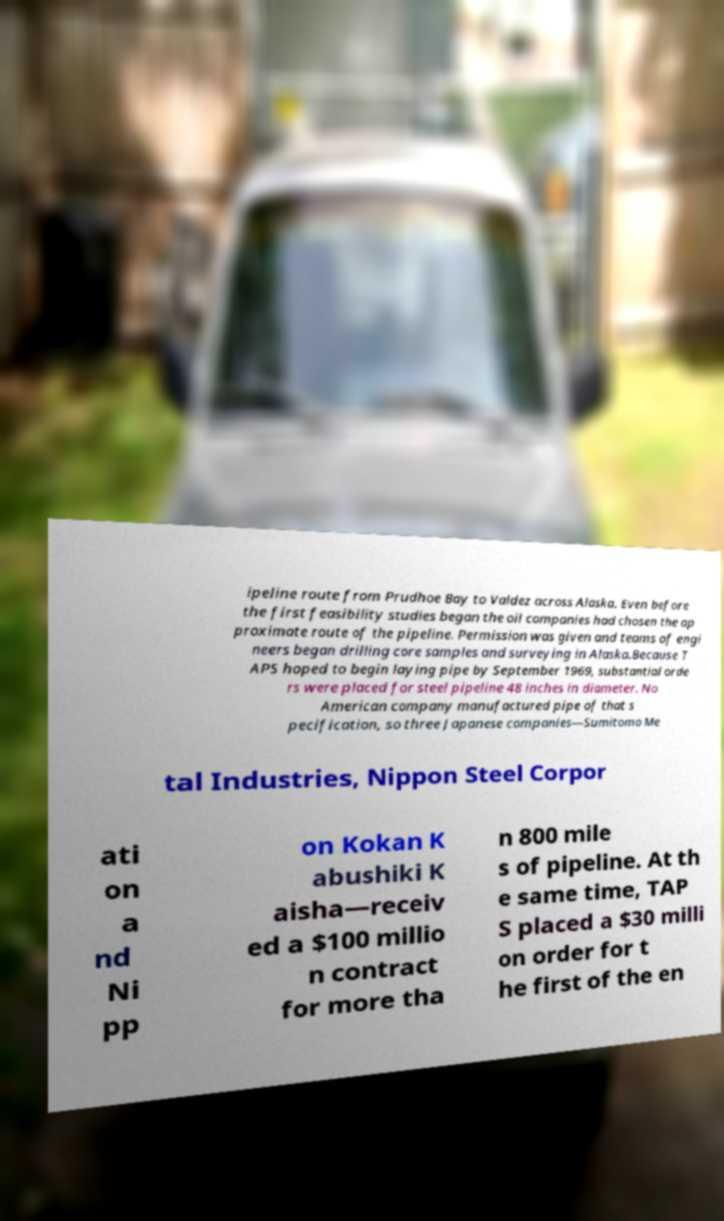Please read and relay the text visible in this image. What does it say? ipeline route from Prudhoe Bay to Valdez across Alaska. Even before the first feasibility studies began the oil companies had chosen the ap proximate route of the pipeline. Permission was given and teams of engi neers began drilling core samples and surveying in Alaska.Because T APS hoped to begin laying pipe by September 1969, substantial orde rs were placed for steel pipeline 48 inches in diameter. No American company manufactured pipe of that s pecification, so three Japanese companies—Sumitomo Me tal Industries, Nippon Steel Corpor ati on a nd Ni pp on Kokan K abushiki K aisha—receiv ed a $100 millio n contract for more tha n 800 mile s of pipeline. At th e same time, TAP S placed a $30 milli on order for t he first of the en 